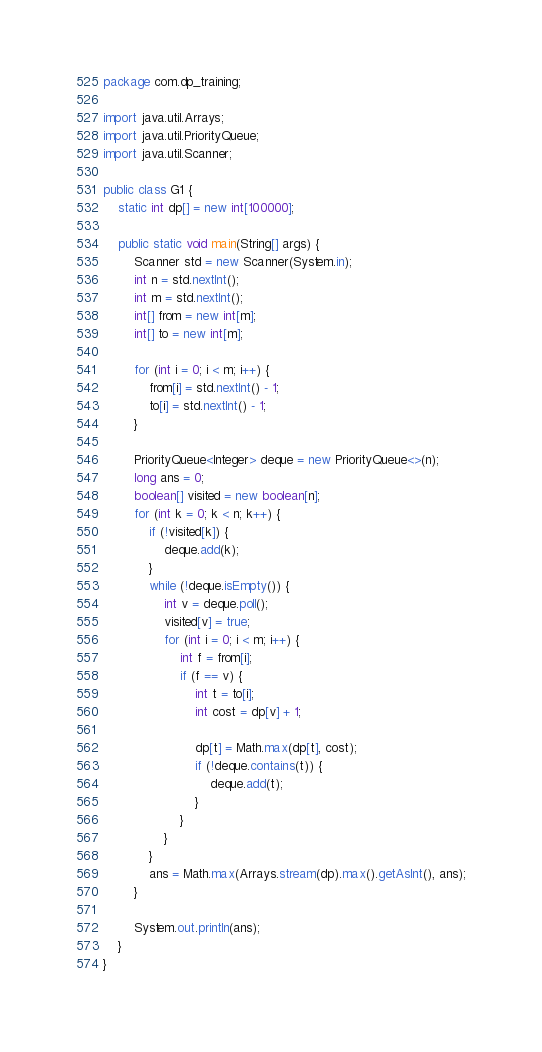Convert code to text. <code><loc_0><loc_0><loc_500><loc_500><_Java_>package com.dp_training;

import java.util.Arrays;
import java.util.PriorityQueue;
import java.util.Scanner;

public class G1 {
    static int dp[] = new int[100000];

    public static void main(String[] args) {
        Scanner std = new Scanner(System.in);
        int n = std.nextInt();
        int m = std.nextInt();
        int[] from = new int[m];
        int[] to = new int[m];

        for (int i = 0; i < m; i++) {
            from[i] = std.nextInt() - 1;
            to[i] = std.nextInt() - 1;
        }

        PriorityQueue<Integer> deque = new PriorityQueue<>(n);
        long ans = 0;
        boolean[] visited = new boolean[n];
        for (int k = 0; k < n; k++) {
            if (!visited[k]) {
                deque.add(k);
            }
            while (!deque.isEmpty()) {
                int v = deque.poll();
                visited[v] = true;
                for (int i = 0; i < m; i++) {
                    int f = from[i];
                    if (f == v) {
                        int t = to[i];
                        int cost = dp[v] + 1;

                        dp[t] = Math.max(dp[t], cost);
                        if (!deque.contains(t)) {
                            deque.add(t);
                        }
                    }
                }
            }
            ans = Math.max(Arrays.stream(dp).max().getAsInt(), ans);
        }

        System.out.println(ans);
    }
}
</code> 